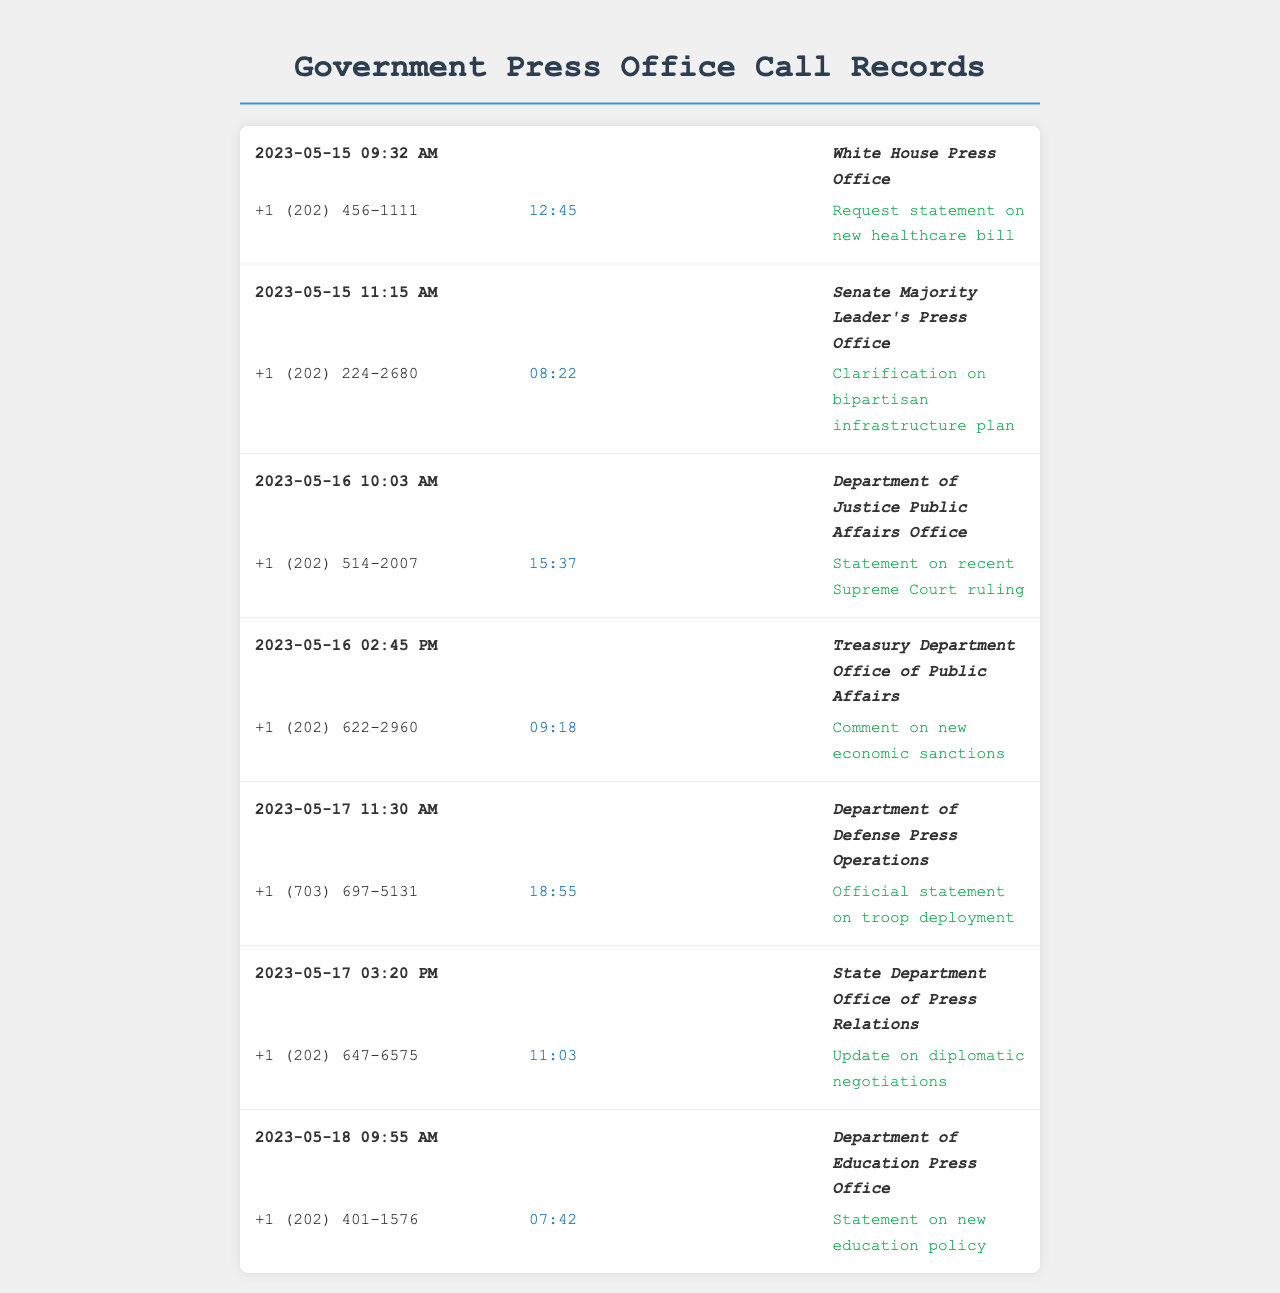What is the date of the call to the White House Press Office? The first call listed was made on May 15, 2023 to the White House Press Office.
Answer: May 15, 2023 Who was contacted at the Treasury Department? The call to the Treasury Department was made to the Office of Public Affairs.
Answer: Treasury Department Office of Public Affairs What was the duration of the call to the Department of Justice? The duration for the call to the Department of Justice Public Affairs Office is included in the document as 15 minutes and 37 seconds.
Answer: 15:37 How many calls were made on May 16, 2023? There are two calls listed for May 16, 2023, one to the Department of Justice and another to the Treasury Department.
Answer: 2 What was the purpose of the call to the Department of Defense? The call to the Department of Defense Press Operations was for an official statement on troop deployment.
Answer: Official statement on troop deployment What time was the last call made? The last call recorded was made at 9:55 AM on May 18, 2023.
Answer: 9:55 AM Which press office was contacted for a statement on new healthcare? The White House Press Office was contacted for a statement on the new healthcare bill.
Answer: White House Press Office What is the total number of unique press offices contacted? The document lists six unique press offices that were contacted for various statements.
Answer: 6 